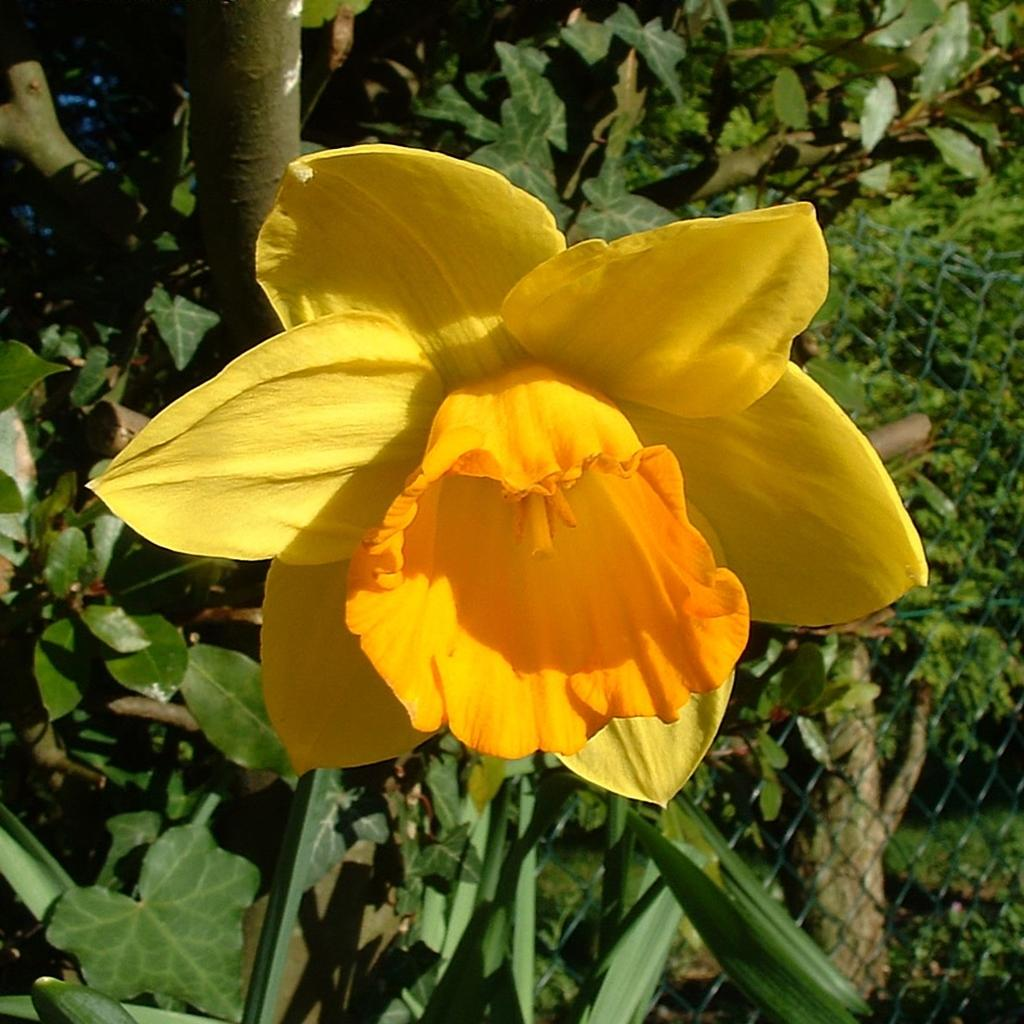What is the main subject of the image? There is a yellow color flower in the middle of the image. What can be seen in the background of the image? There are plants in the background of the image. Where is the net fencing located in the image? The net fencing is in the bottom right-hand corner of the image. Can you hear the sound of the sign in the image? There is no sign present in the image, so it is not possible to hear any sound related to it. 